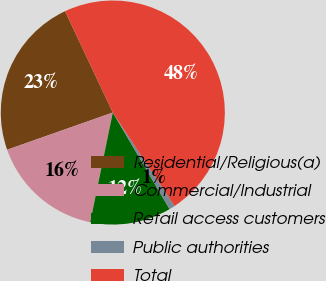<chart> <loc_0><loc_0><loc_500><loc_500><pie_chart><fcel>Residential/Religious(a)<fcel>Commercial/Industrial<fcel>Retail access customers<fcel>Public authorities<fcel>Total<nl><fcel>23.38%<fcel>16.38%<fcel>11.69%<fcel>0.82%<fcel>47.73%<nl></chart> 